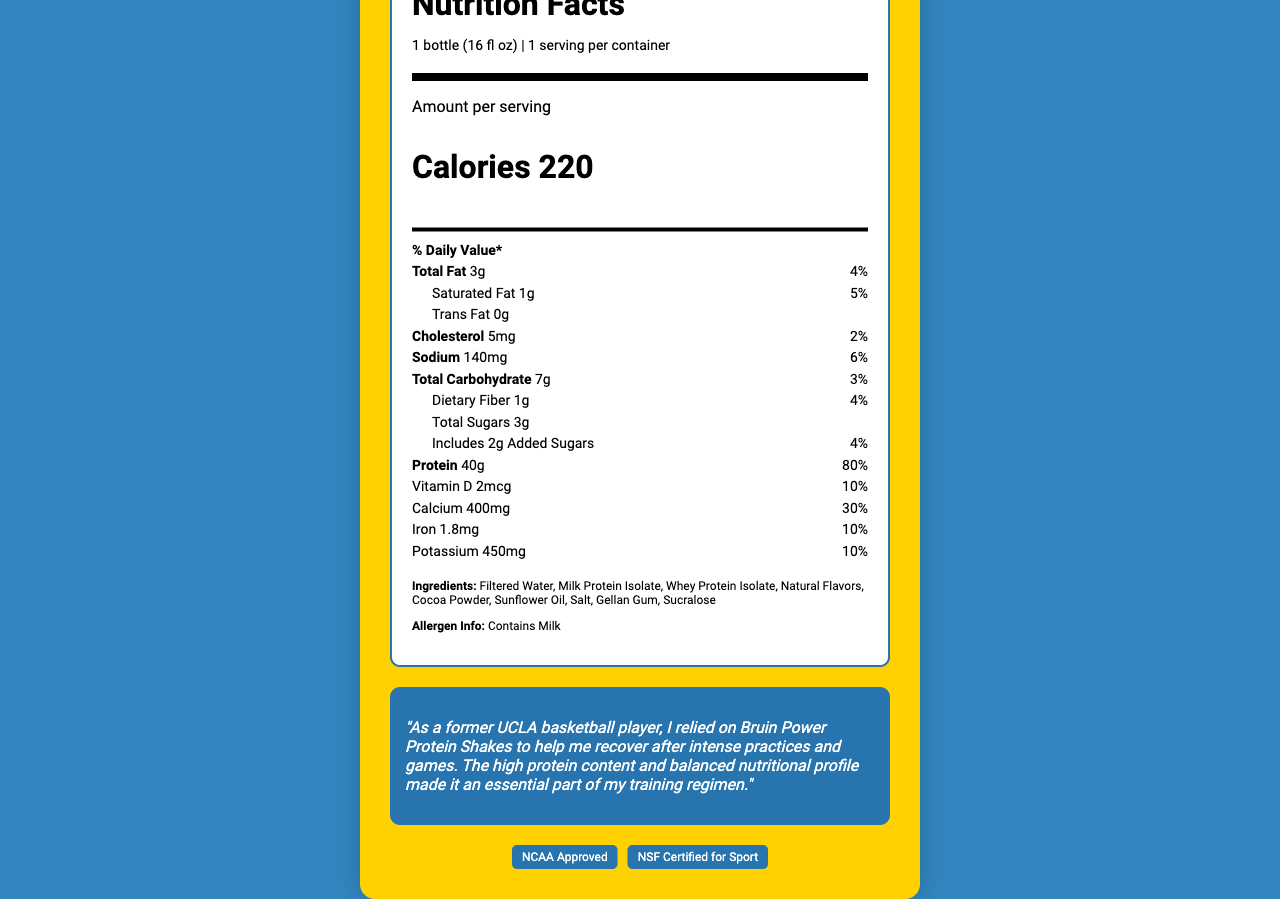what is the product name? The title of the document clearly states "Bruin Power Protein Shake".
Answer: Bruin Power Protein Shake what is the serving size for the Bruin Power Protein Shake? The serving size is mentioned under the "Nutrition Facts" header.
Answer: 1 bottle (16 fl oz) how many calories are in one serving of the Bruin Power Protein Shake? The calories per serving are listed prominently under the "Amount per serving" section.
Answer: 220 what percentage of the daily value for protein does one bottle provide? The percentage daily value for protein is listed next to the protein amount.
Answer: 80% how much total fat does one serving contain? The total fat content is stated as 3g in the nutrient section.
Answer: 3g what certifications does the Bruin Power Protein Shake have? A. Non-GMO B. NSF Certified for Sport C. USDA Organic D. NCAA Approved The document mentions that the product is "NCAA Approved" and "NSF Certified for Sport".
Answer: B and D what is the sodium content in one serving and its daily value percentage? The sodium content is listed as 140mg, which is 6% of the daily value.
Answer: 140mg, 6% does the product contain any added sugars? The document states that the product includes 2g of added sugars.
Answer: Yes who endorses the Bruin Power Protein Shake? The document includes a coach endorsement from Coach Mick Cronin.
Answer: Coach Mick Cronin is the Bruin Power Protein Shake suitable for someone with a milk allergy? The allergen information states that it contains milk.
Answer: No describe the overall nutritional profile and other key features of the Bruin Power Protein Shake. The document contains detailed information on calories, macronutrients, micronutrients, endorsements, certifications, and availability locations.
Answer: The Bruin Power Protein Shake provides 220 calories per serving, with a significant protein content of 40g, contributing 80% of the daily value. It has low fat and sugar content but is rich in essential minerals like calcium, potassium, and iron. The shake is endorsed by Coach Mick Cronin, has certifications like NCAA Approved and NSF Certified for Sport, and is available at various UCLA locations. where can you purchase the Bruin Power Protein Shake on the UCLA campus? The document lists the available locations for purchasing the shake.
Answer: UCLA Athletic Department, John Wooden Center, Bruin Cafe, Ackerman Union does the product contain gluten? The document does not provide information about gluten content.
Answer: Cannot be determined how much vitamin D does one serving provide? A. 2mcg B. 10mcg C. 4mcg D. 5mcg The vitamin D content per serving is stated as 2mcg.
Answer: A. 2mcg does the Bruin Power Protein Shake contain any trans fats? The document states that the amount of trans fat is 0g.
Answer: No what is the main ingredient of the Bruin Power Protein Shake? The ingredient list begins with "Filtered Water", indicating it is the primary ingredient.
Answer: Filtered Water 